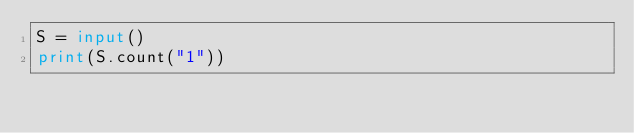Convert code to text. <code><loc_0><loc_0><loc_500><loc_500><_Python_>S = input()
print(S.count("1"))</code> 